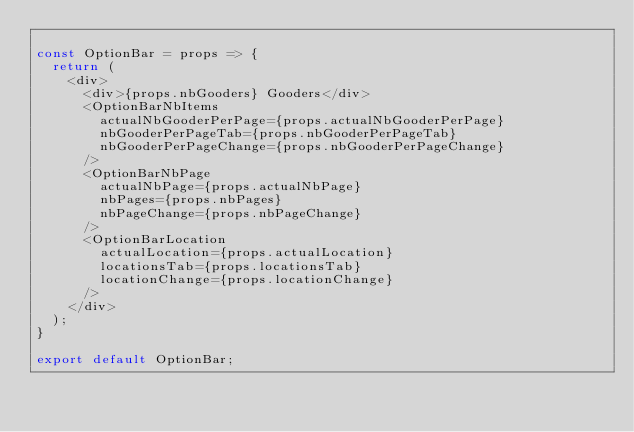<code> <loc_0><loc_0><loc_500><loc_500><_JavaScript_>
const OptionBar = props => {
  return (
    <div>
      <div>{props.nbGooders} Gooders</div>
      <OptionBarNbItems
        actualNbGooderPerPage={props.actualNbGooderPerPage}
        nbGooderPerPageTab={props.nbGooderPerPageTab}
        nbGooderPerPageChange={props.nbGooderPerPageChange}
      />
      <OptionBarNbPage
        actualNbPage={props.actualNbPage}
        nbPages={props.nbPages}
        nbPageChange={props.nbPageChange}
      />
      <OptionBarLocation
        actualLocation={props.actualLocation}
        locationsTab={props.locationsTab}
        locationChange={props.locationChange}
      />
    </div>
  );
}

export default OptionBar;

</code> 